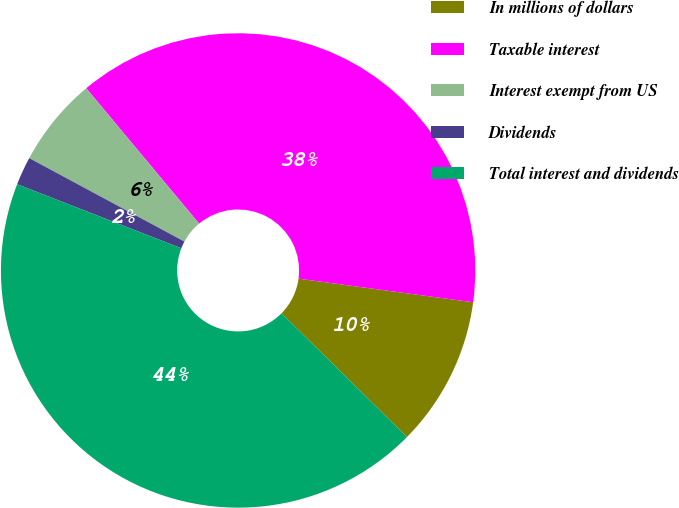<chart> <loc_0><loc_0><loc_500><loc_500><pie_chart><fcel>In millions of dollars<fcel>Taxable interest<fcel>Interest exempt from US<fcel>Dividends<fcel>Total interest and dividends<nl><fcel>10.25%<fcel>38.2%<fcel>6.09%<fcel>1.93%<fcel>43.53%<nl></chart> 